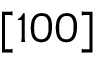Convert formula to latex. <formula><loc_0><loc_0><loc_500><loc_500>[ 1 0 0 ]</formula> 